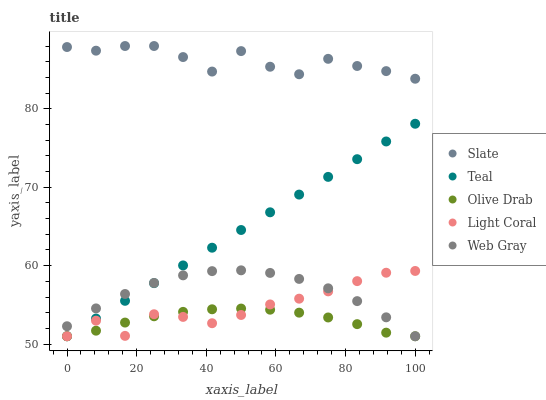Does Olive Drab have the minimum area under the curve?
Answer yes or no. Yes. Does Slate have the maximum area under the curve?
Answer yes or no. Yes. Does Web Gray have the minimum area under the curve?
Answer yes or no. No. Does Web Gray have the maximum area under the curve?
Answer yes or no. No. Is Teal the smoothest?
Answer yes or no. Yes. Is Slate the roughest?
Answer yes or no. Yes. Is Web Gray the smoothest?
Answer yes or no. No. Is Web Gray the roughest?
Answer yes or no. No. Does Light Coral have the lowest value?
Answer yes or no. Yes. Does Slate have the lowest value?
Answer yes or no. No. Does Slate have the highest value?
Answer yes or no. Yes. Does Web Gray have the highest value?
Answer yes or no. No. Is Web Gray less than Slate?
Answer yes or no. Yes. Is Slate greater than Web Gray?
Answer yes or no. Yes. Does Web Gray intersect Olive Drab?
Answer yes or no. Yes. Is Web Gray less than Olive Drab?
Answer yes or no. No. Is Web Gray greater than Olive Drab?
Answer yes or no. No. Does Web Gray intersect Slate?
Answer yes or no. No. 